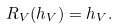Convert formula to latex. <formula><loc_0><loc_0><loc_500><loc_500>R _ { V } ( h _ { V } ) = h _ { V } .</formula> 